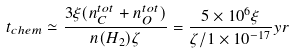Convert formula to latex. <formula><loc_0><loc_0><loc_500><loc_500>t _ { c h e m } \simeq \frac { 3 \xi ( n _ { C } ^ { t o t } + n _ { O } ^ { t o t } ) } { n ( H _ { 2 } ) \zeta } = \frac { 5 \times 1 0 ^ { 6 } \xi } { \zeta / 1 \times 1 0 ^ { - 1 7 } } y r</formula> 